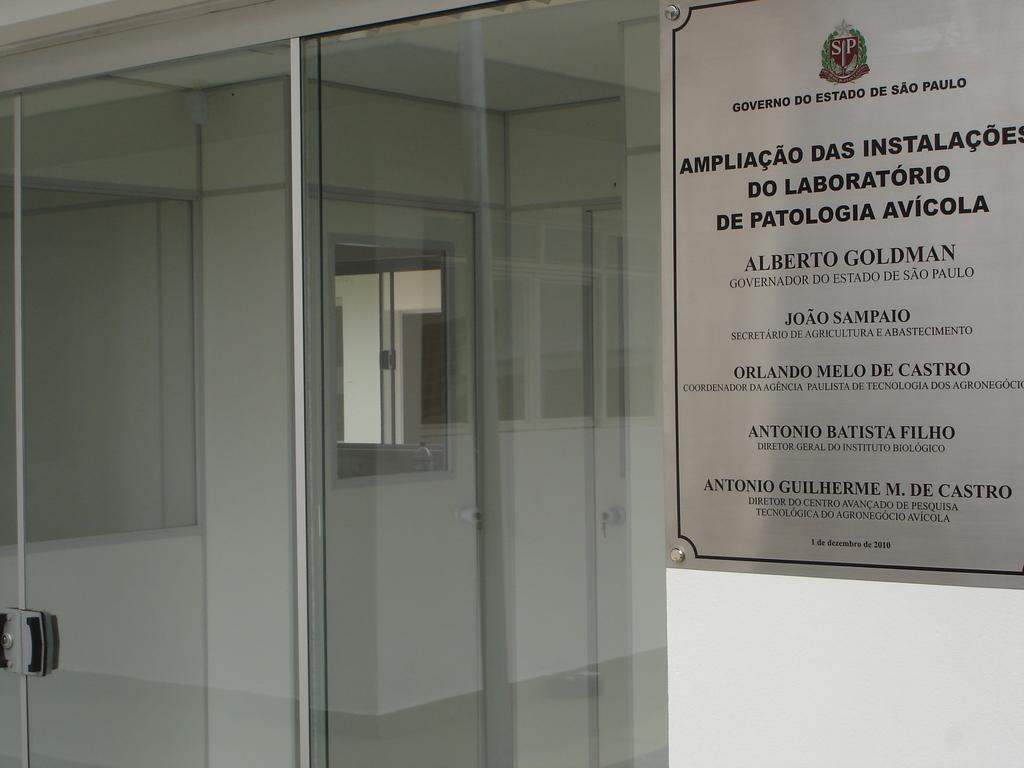<image>
Summarize the visual content of the image. A government sign from Sao Paulo dated 2010. 